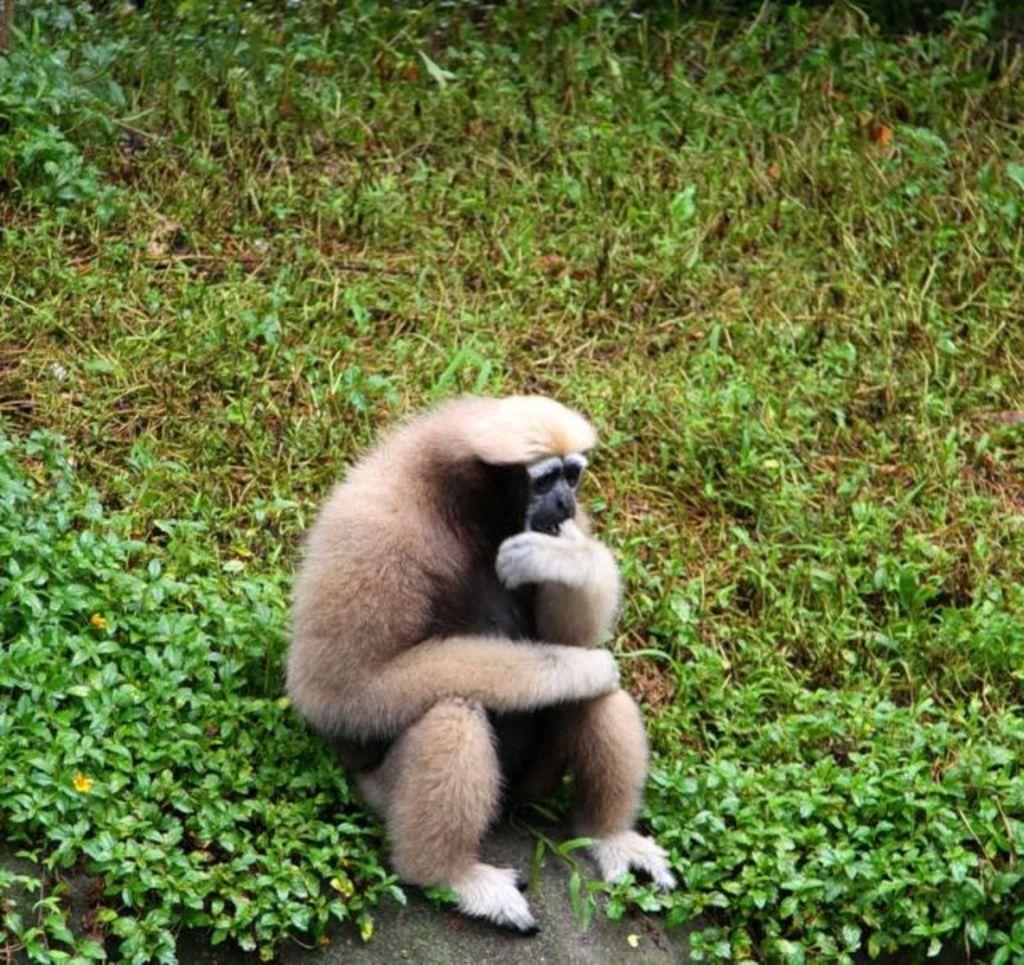Please provide a concise description of this image. In the image there is a monkey sitting on a grassland. 